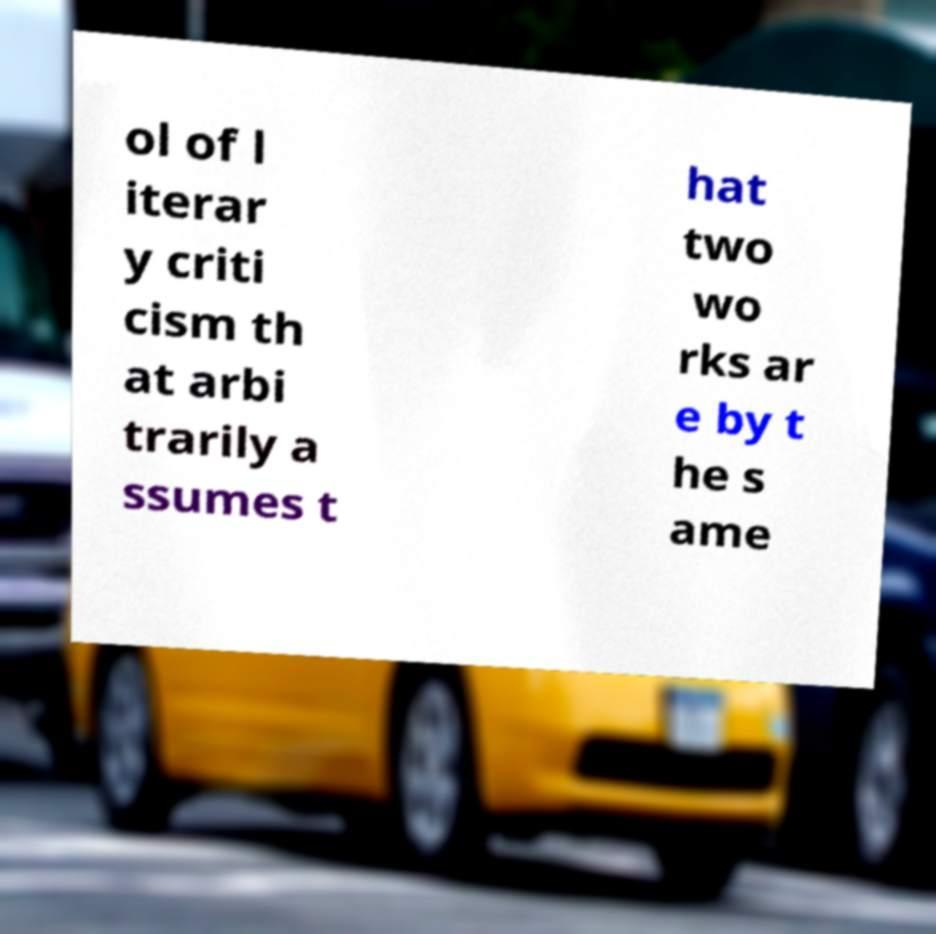What messages or text are displayed in this image? I need them in a readable, typed format. ol of l iterar y criti cism th at arbi trarily a ssumes t hat two wo rks ar e by t he s ame 